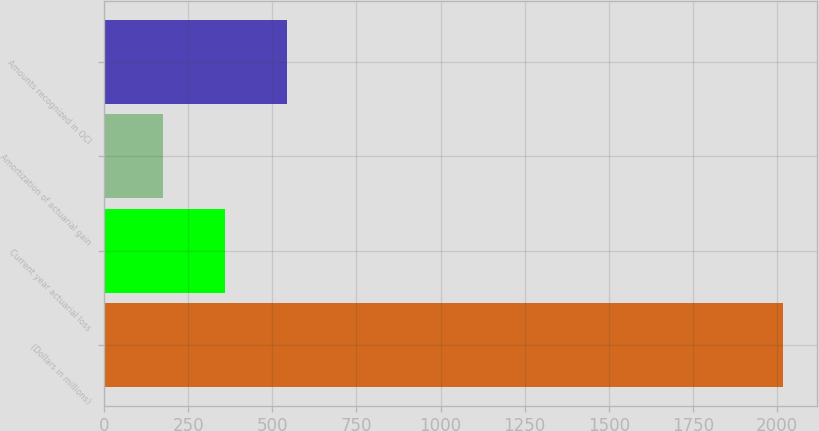Convert chart. <chart><loc_0><loc_0><loc_500><loc_500><bar_chart><fcel>(Dollars in millions)<fcel>Current year actuarial loss<fcel>Amortization of actuarial gain<fcel>Amounts recognized in OCI<nl><fcel>2017<fcel>359.2<fcel>175<fcel>543.4<nl></chart> 